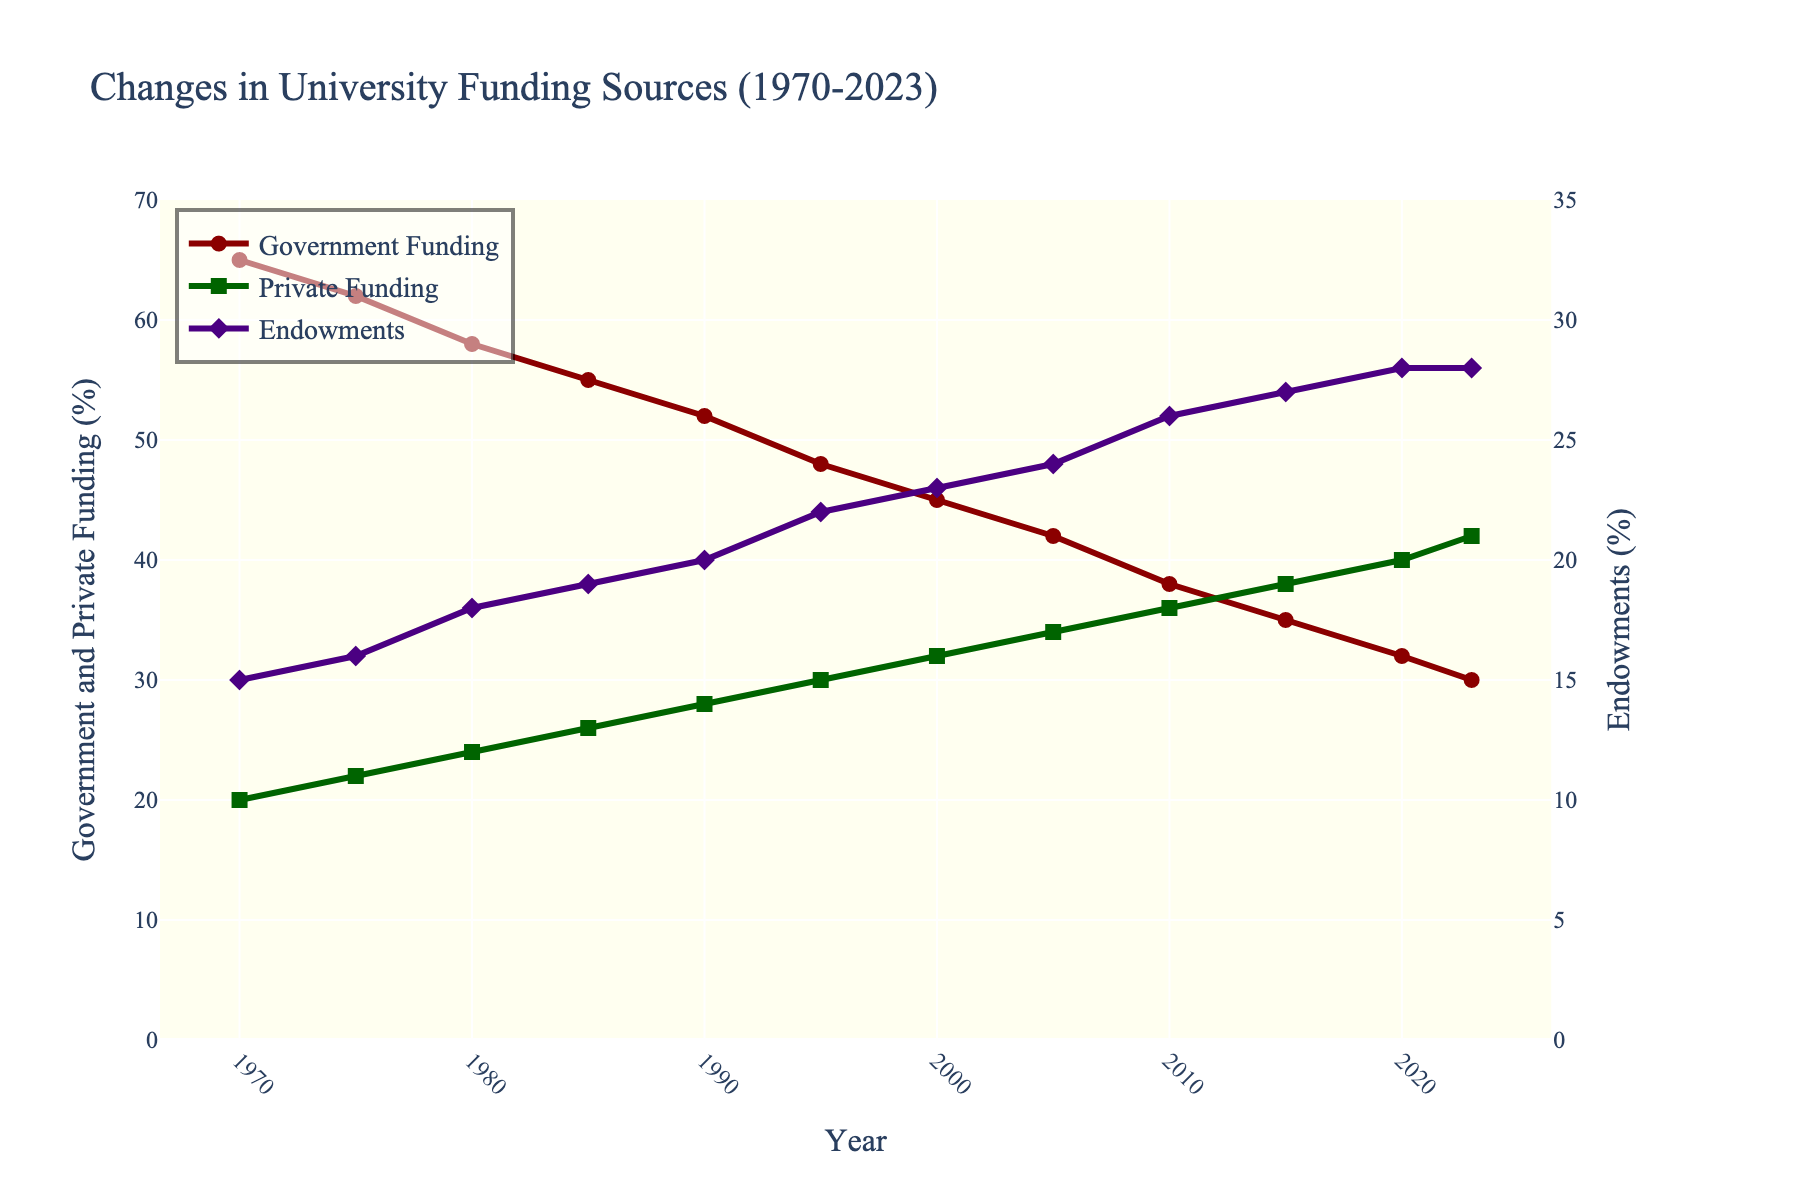Which year had the highest percentage of government funding, and what was the percentage? To answer this, look at the 'Government Funding (%)' line and identify the highest point. The highest point occurs in 1970 with a percentage of 65%.
Answer: 1970, 65% How did the percentage of private funding change from 1970 to 2023? To determine the change, subtract the value of private funding in 1970 from the value in 2023. Private funding in 2023 is 42%, and in 1970 it was 20%. The change is 42% - 20% = 22%.
Answer: Increase by 22% What is the average percentage of endowments from 1970 to 2023? To calculate the average, add all the percentages of endowments from each year and divide by the number of years. Sum = 15 + 16 + 18 + 19 + 20 + 22 + 23 + 24 + 26 + 27 + 28 + 28 = 266. Average = 266 / 12 = 22.17%.
Answer: 22.17% In which years did the government funding decline while endowment funding increased? Look for years where the 'Government Funding (%)' line decreases and 'Endowments (%)' line increases between consecutive points. This occurs between 1970-75, 1975-80, 1980-85, 1985-90, 1990-95, 1995-2000, 2000-2005, 2005-2010, and 2010-2015.
Answer: 1970-75, 1975-80, 1980-85, 1985-90, 1990-95, 1995-2000, 2000-2005, 2005-2010, 2010-2015 Which funding source showed the most significant relative increase from 1970 to 2023? Calculate the percentage increase for each funding source. Government: (30% - 65%) / 65% = -53.8%. Private: (42% - 20%) / 20% = 110%. Endowments: (28% - 15%) / 15% = 86.7%. The most significant relative increase is for private funding at 110%.
Answer: Private funding In what year did private funding equal 34% and what was the percentage of government funding in that year? Locate the year where private funding was 34%, which is in 2005. The percentage of government funding in 2005 was 42%.
Answer: 2005, 42% How much did total funding from government and private sources change from 1990 to 2023? Add the government and private funding percentages for each year and then find the difference. In 1990: Government 52% + Private 28% = 80%. In 2023: Government 30% + Private 42% = 72%. The change is 80% - 72% = 8%.
Answer: Decreased by 8% By how much did endowment funding increase from 1980 to 2020? Subtract the percentage of endowment funding in 1980 from that in 2020. Endowment funding in 1980 is 18%, and in 2020 it is 28%. The increase is 28% - 18% = 10%.
Answer: 10% Which funding source was the most stable over the period 1970 to 2023? Determine stability by assessing the line's fluctuations. The 'Endowments (%)' line shows the least variability compared to the 'Government Funding (%)' and 'Private Funding (%)' lines.
Answer: Endowments 